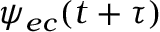Convert formula to latex. <formula><loc_0><loc_0><loc_500><loc_500>\psi _ { e c } ( t + \tau )</formula> 